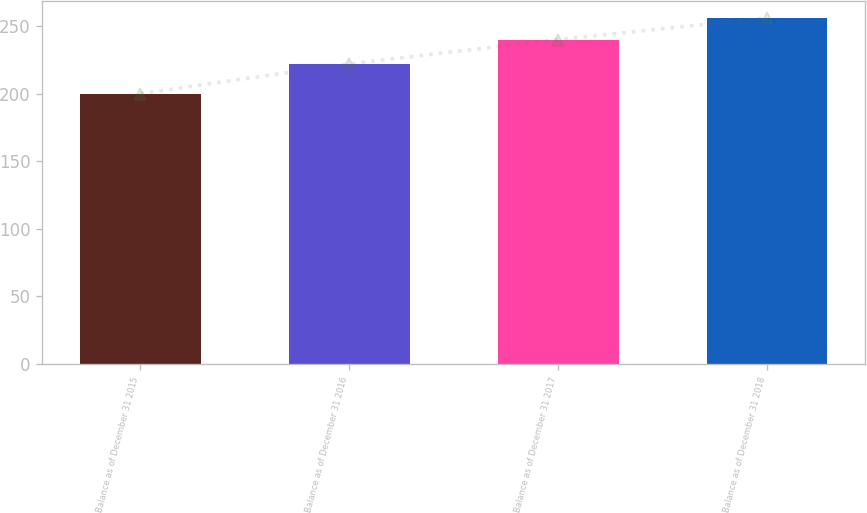Convert chart to OTSL. <chart><loc_0><loc_0><loc_500><loc_500><bar_chart><fcel>Balance as of December 31 2015<fcel>Balance as of December 31 2016<fcel>Balance as of December 31 2017<fcel>Balance as of December 31 2018<nl><fcel>200<fcel>222<fcel>240<fcel>256<nl></chart> 